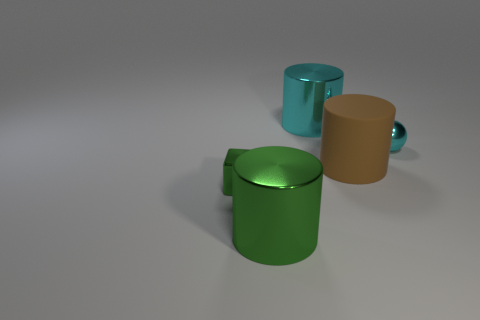Add 3 large rubber cylinders. How many objects exist? 8 Subtract all balls. How many objects are left? 4 Subtract 1 green blocks. How many objects are left? 4 Subtract all green blocks. Subtract all blue matte things. How many objects are left? 4 Add 1 big cyan things. How many big cyan things are left? 2 Add 5 big red rubber blocks. How many big red rubber blocks exist? 5 